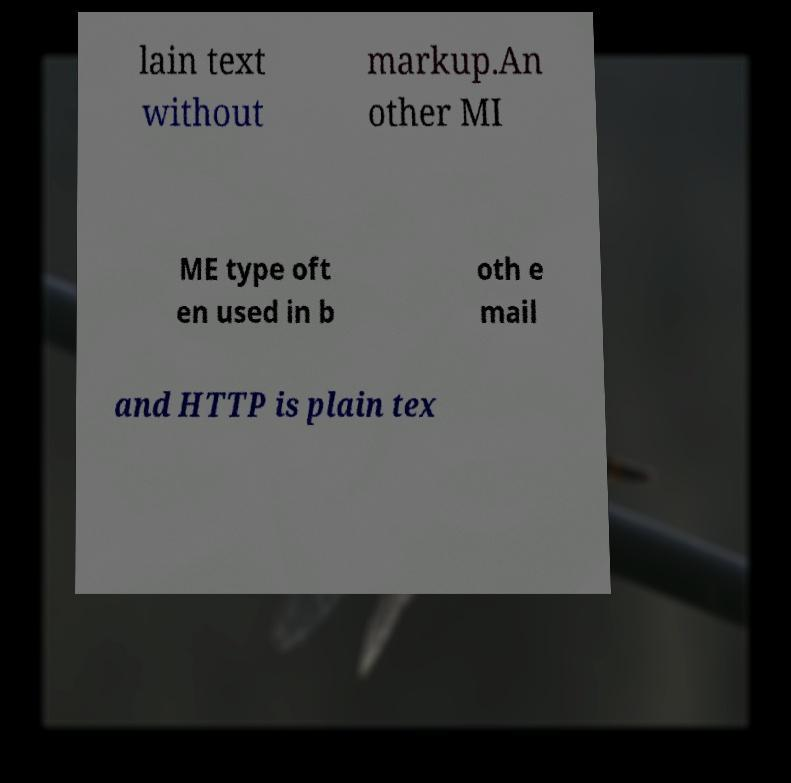Could you extract and type out the text from this image? lain text without markup.An other MI ME type oft en used in b oth e mail and HTTP is plain tex 